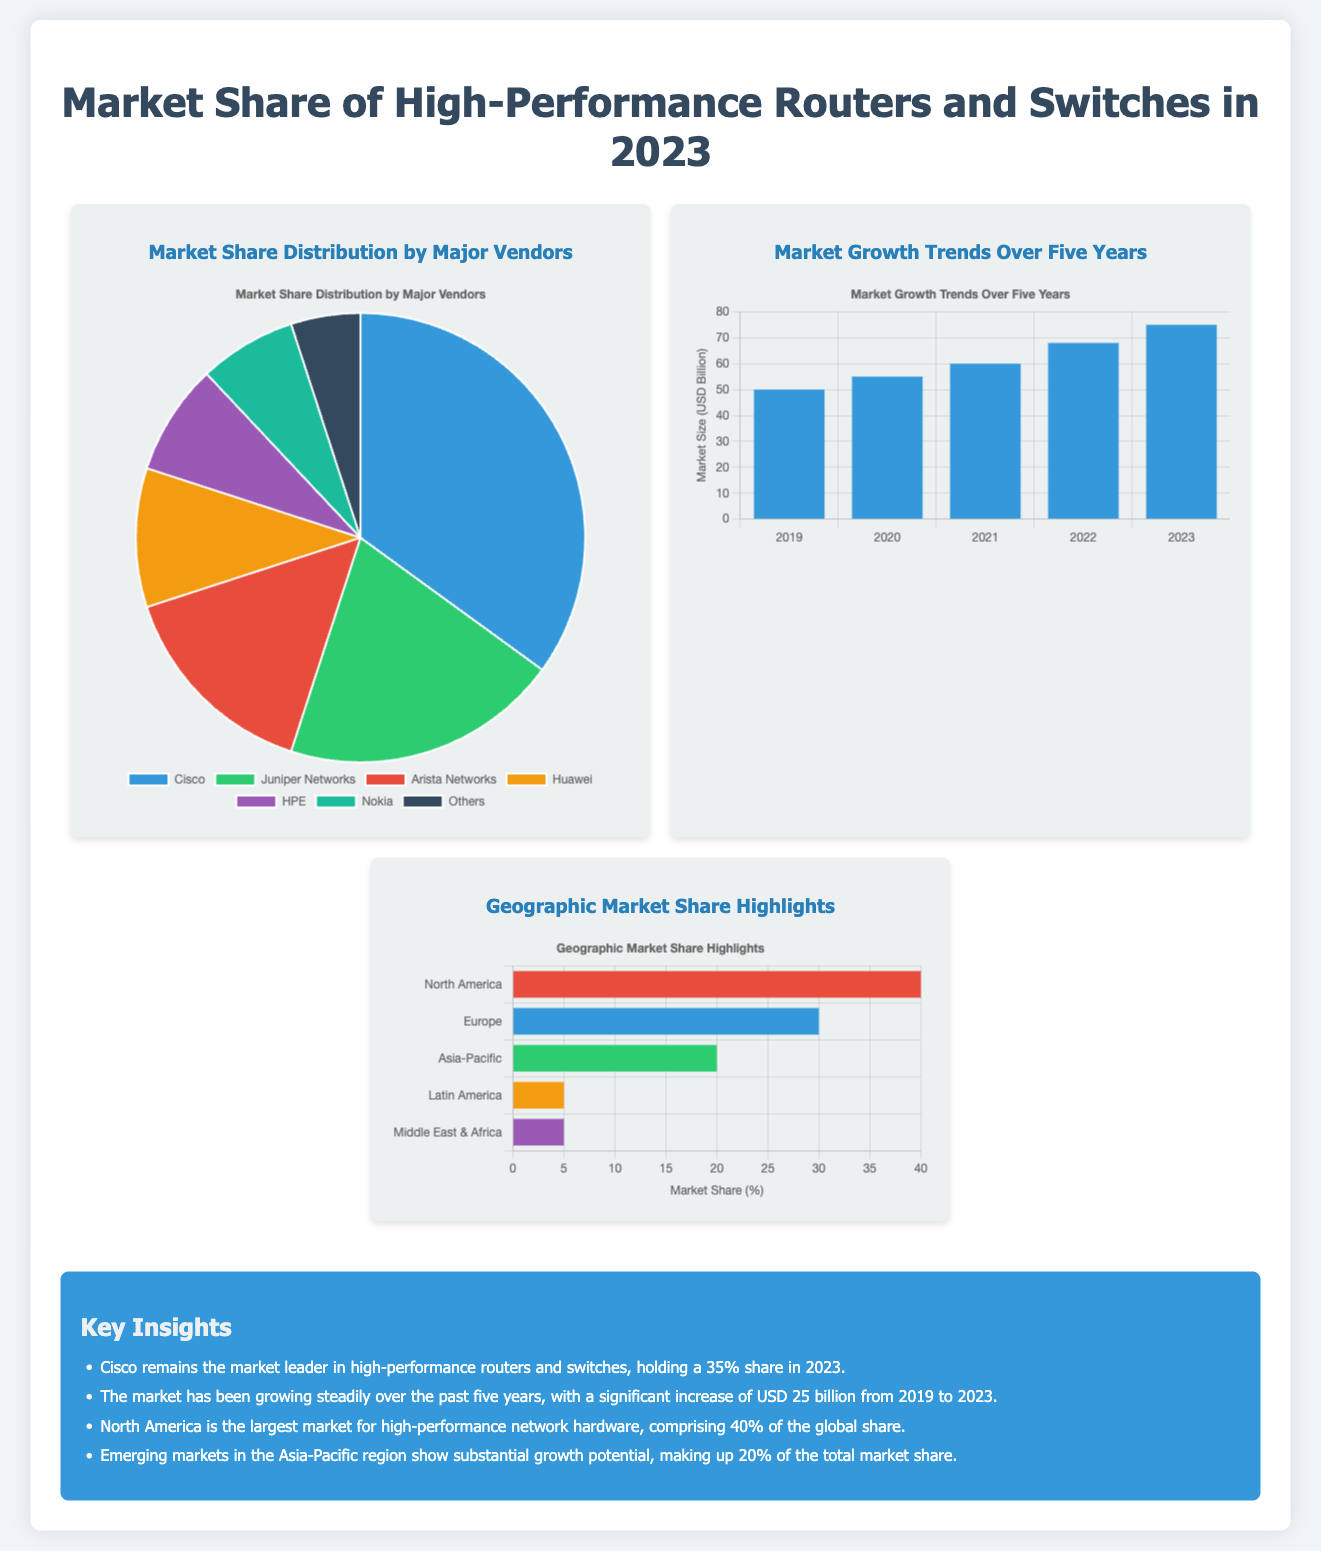What is Cisco's market share in 2023? Cisco holds a 35% share in the high-performance routers and switches market for 2023.
Answer: 35% Which company has a larger market share, Juniper Networks or Arista Networks? Juniper Networks has a market share of 20%, which is greater than Arista Networks' 15%.
Answer: Juniper Networks How much has the market increased from 2019 to 2023? The document states there was a significant increase of USD 25 billion over this period.
Answer: 25 billion Which region comprises 40% of the global market share? North America is highlighted as the largest market, comprising 40% of the share.
Answer: North America What is the total market size in USD billion for 2023? The market size for 2023 is presented as USD 75 billion in the bar graph showing growth trends.
Answer: 75 billion What type of chart represents the geographic market share highlights? The geographic market share highlights are represented as a horizontal bar chart.
Answer: Horizontal bar chart Which vendor is categorized under 'Others' in the market share pie chart? The 'Others' category includes all vendors not listed separately, implying multiple smaller vendors.
Answer: Others Which region shows significant growth potential? The Asia-Pacific region is noted for its substantial growth potential.
Answer: Asia-Pacific 